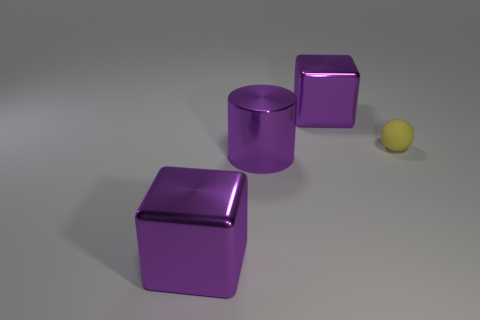There is a large object that is right of the large purple cylinder in front of the purple object that is behind the rubber object; what shape is it? cube 